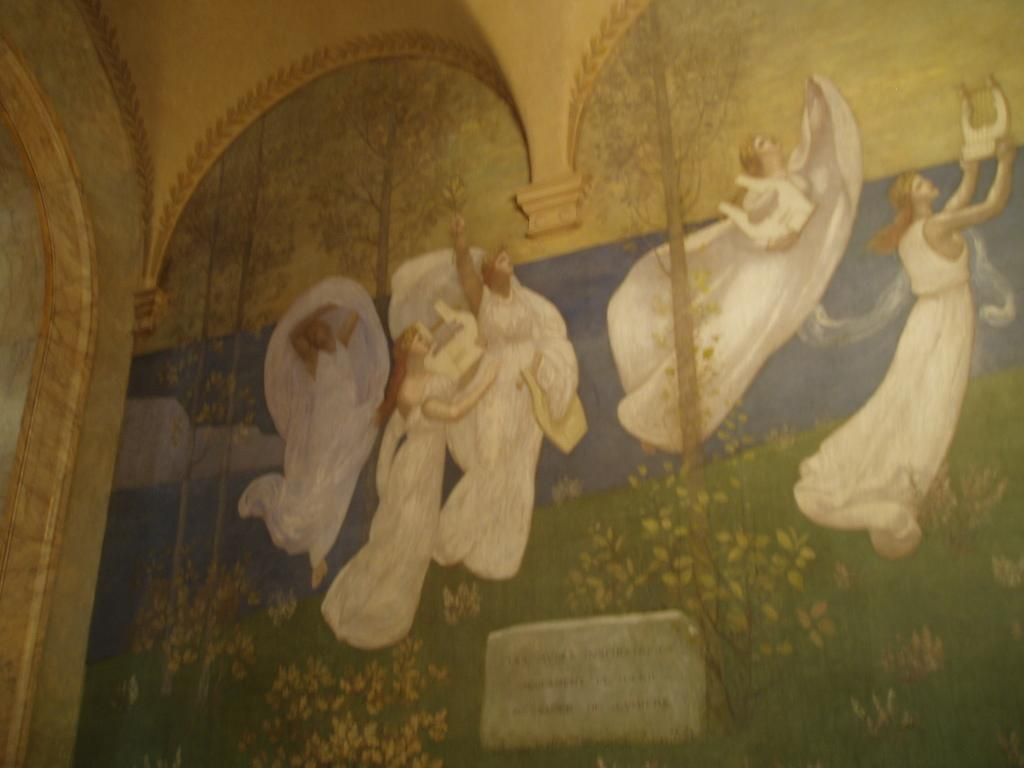What is hanging on the wall in the image? There is a painting on the wall in the image. Can you describe the people in the image? There is a group of people in the image. What is depicted in the painting on the wall? The painting on the wall features plants and trees. How many cherries are hanging from the giraffe's neck in the image? There is no giraffe or cherries present in the image. What shape is the square depicted in the painting on the wall? There is no square depicted in the painting on the wall; it features plants and trees. 